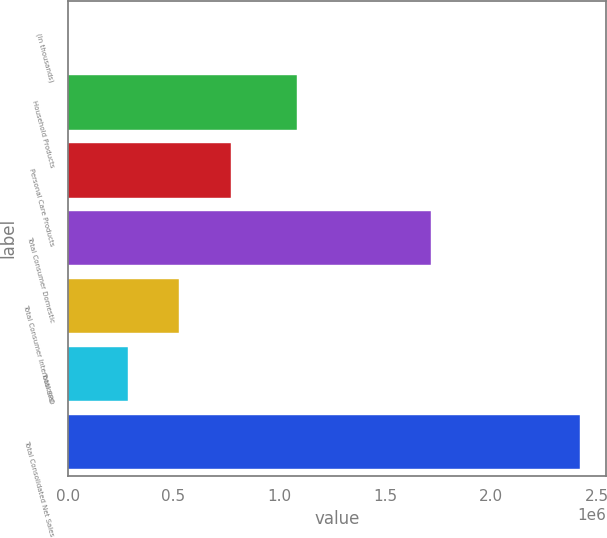<chart> <loc_0><loc_0><loc_500><loc_500><bar_chart><fcel>(In thousands)<fcel>Household Products<fcel>Personal Care Products<fcel>Total Consumer Domestic<fcel>Total Consumer International<fcel>Total SPD<fcel>Total Consolidated Net Sales<nl><fcel>2008<fcel>1.08144e+06<fcel>769483<fcel>1.7168e+06<fcel>527444<fcel>285405<fcel>2.4224e+06<nl></chart> 